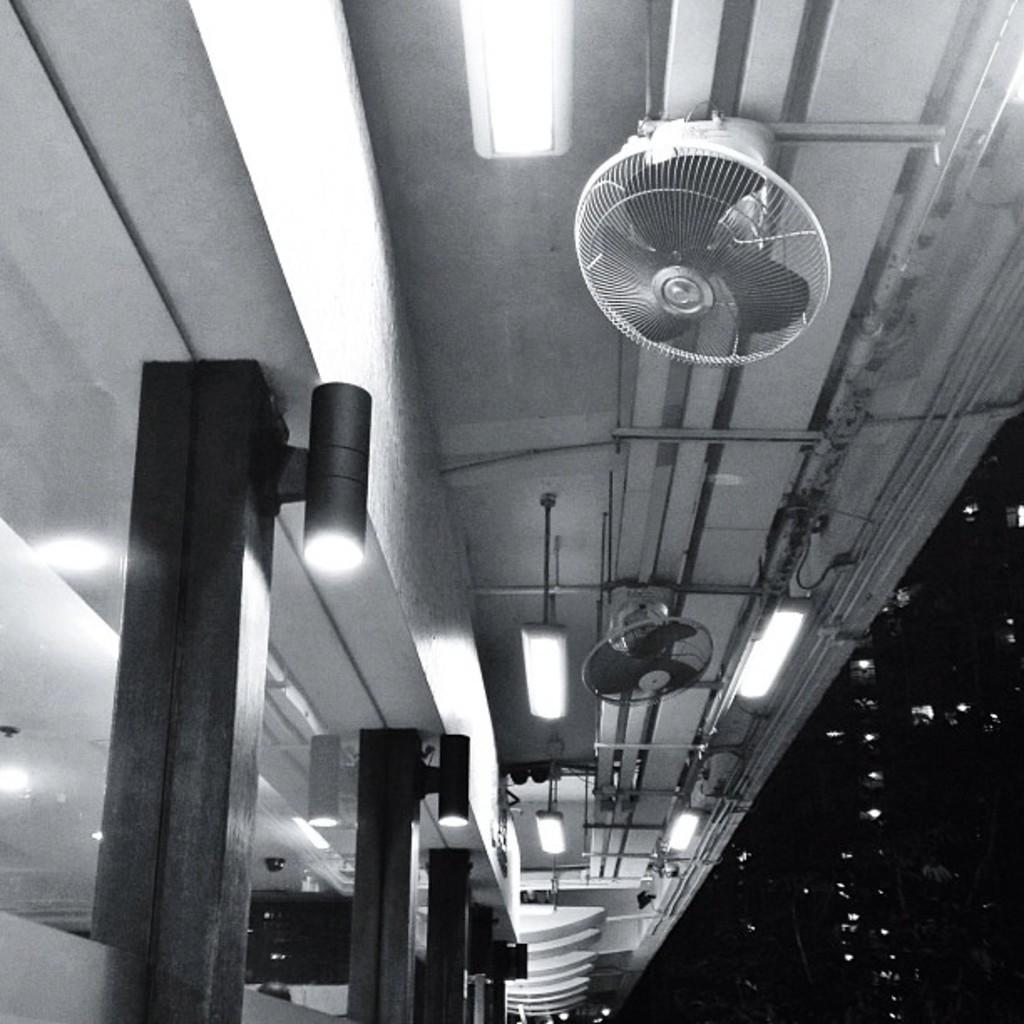What type of objects can be seen in the image? There are fans, lights, and glass in the image. What else is present in the image besides the fans, lights, and glass? There are unspecified objects in the image. How can you describe the background of the image? The background of the image is dark. What action is the glass performing in the image? The glass is an inanimate object and does not perform actions in the image. 